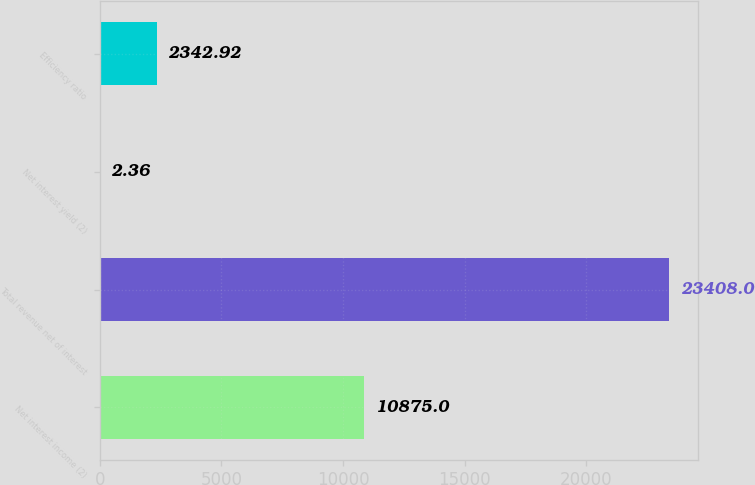<chart> <loc_0><loc_0><loc_500><loc_500><bar_chart><fcel>Net interest income (2)<fcel>Total revenue net of interest<fcel>Net interest yield (2)<fcel>Efficiency ratio<nl><fcel>10875<fcel>23408<fcel>2.36<fcel>2342.92<nl></chart> 